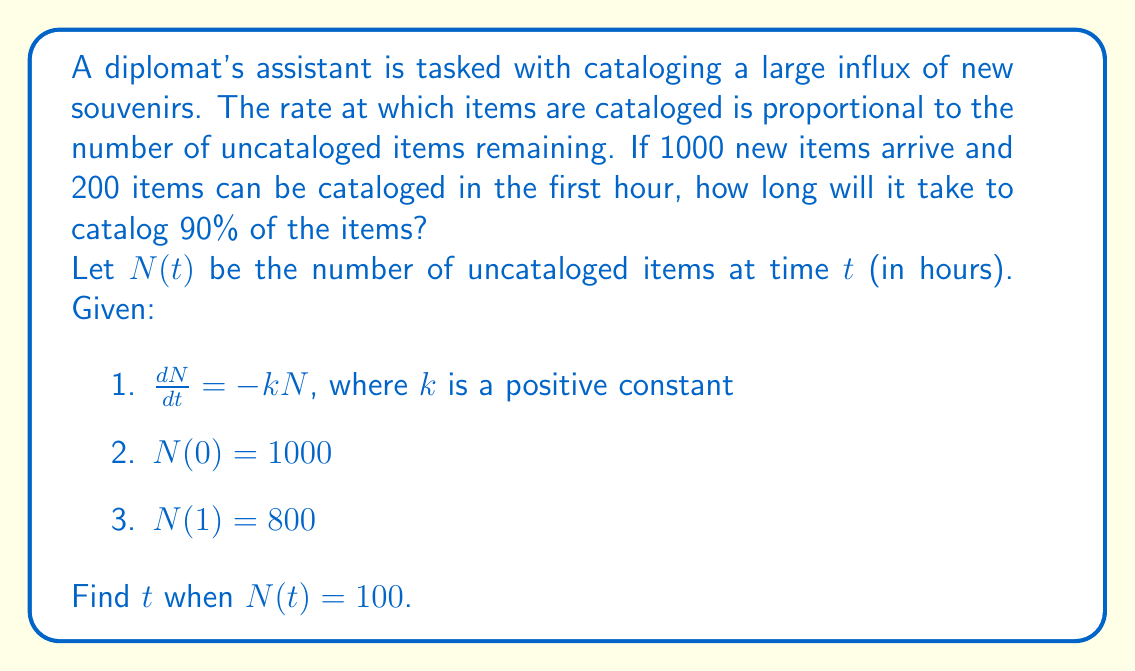Show me your answer to this math problem. To solve this first-order differential equation, we'll follow these steps:

1) First, we need to find the value of $k$. We can use the given information that $N(1) = 800$:

   $N(t) = N_0e^{-kt}$, where $N_0 = N(0) = 1000$

   $800 = 1000e^{-k(1)}$
   $0.8 = e^{-k}$
   $\ln(0.8) = -k$
   $k = -\ln(0.8) \approx 0.2231$

2) Now that we have $k$, we can use the general solution to find $t$ when $N(t) = 100$:

   $100 = 1000e^{-0.2231t}$
   $0.1 = e^{-0.2231t}$
   $\ln(0.1) = -0.2231t$
   $t = \frac{\ln(0.1)}{-0.2231} \approx 10.3224$

Therefore, it will take approximately 10.32 hours to catalog 90% of the items.
Answer: 10.32 hours 